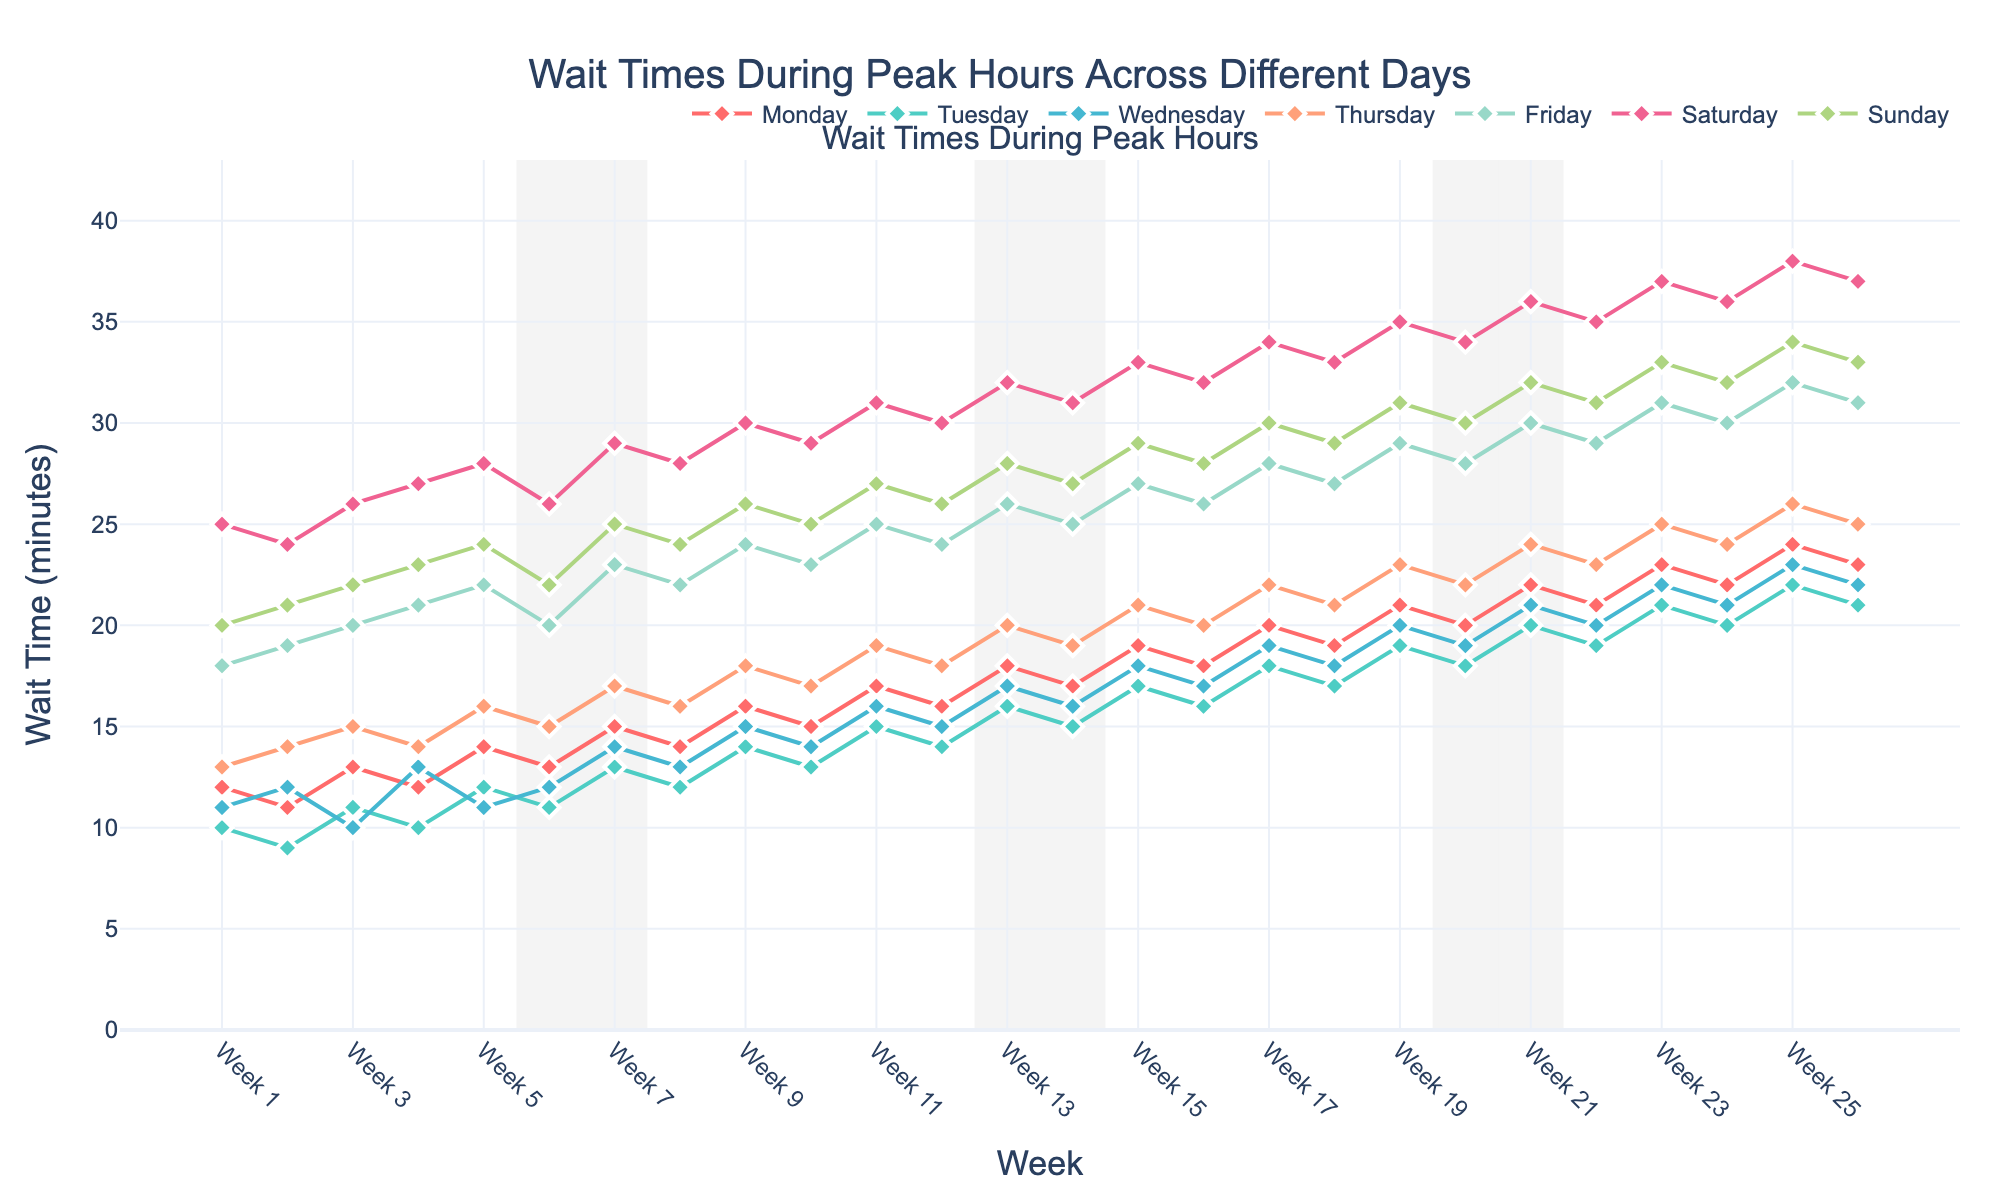what's the average wait time for Tuesday in Weeks 1 to 4? Sum the wait times for Tuesday in Weeks 1 to 4: (10 + 9 + 11 + 10) = 40. There are 4 weeks, so the average is 40 / 4 = 10
Answer: 10 Which day has the highest wait time in Week 23? In Week 23, the wait times are Monday: 23, Tuesday: 21, Wednesday: 22, Thursday: 25, Friday: 31, Saturday: 37, Sunday: 33. The highest value is for Saturday with 37 minutes
Answer: Saturday How does the wait time trend on Mondays compare from Week 1 to Week 26? The wait time on Mondays increases from 12 minutes in Week 1 to 24 minutes in Week 26. Observing the line plot for Monday shows a general upward trend over the weeks
Answer: Increases What's the difference in wait times between Saturday and Sunday in Week 10? In Week 10, the wait time for Saturday is 29 and for Sunday is 25. The difference is calculated as 29 - 25 = 4
Answer: 4 Which week has the highest average wait time across all days? Calculate the average wait time for each week:
- For Week 1: (12+10+11+13+18+25+20)/7 ≈ 15.57
- Repeating this calculation for each week, Week 21 has the highest average with (22+20+21+24+30+36+32)/7 ≈ 26.43
Answer: Week 21 Are there more fluctuations in wait times on weekdays (Monday to Friday) or weekends (Saturday and Sunday)? Weekdays show more consistent lines with smaller upward trends. Weekends have higher fluctuations with sudden increases at certain points in the graph, especially on Saturday with large increasing spikes
Answer: Weekends What's the overall trend for wait times on Fridays from Week 1 to Week 26? By observing the line graph for Fridays, we see a steady increase from 18 minutes in Week 1 to 32 minutes in Week 26, indicating a general upward trend
Answer: Upward trend 